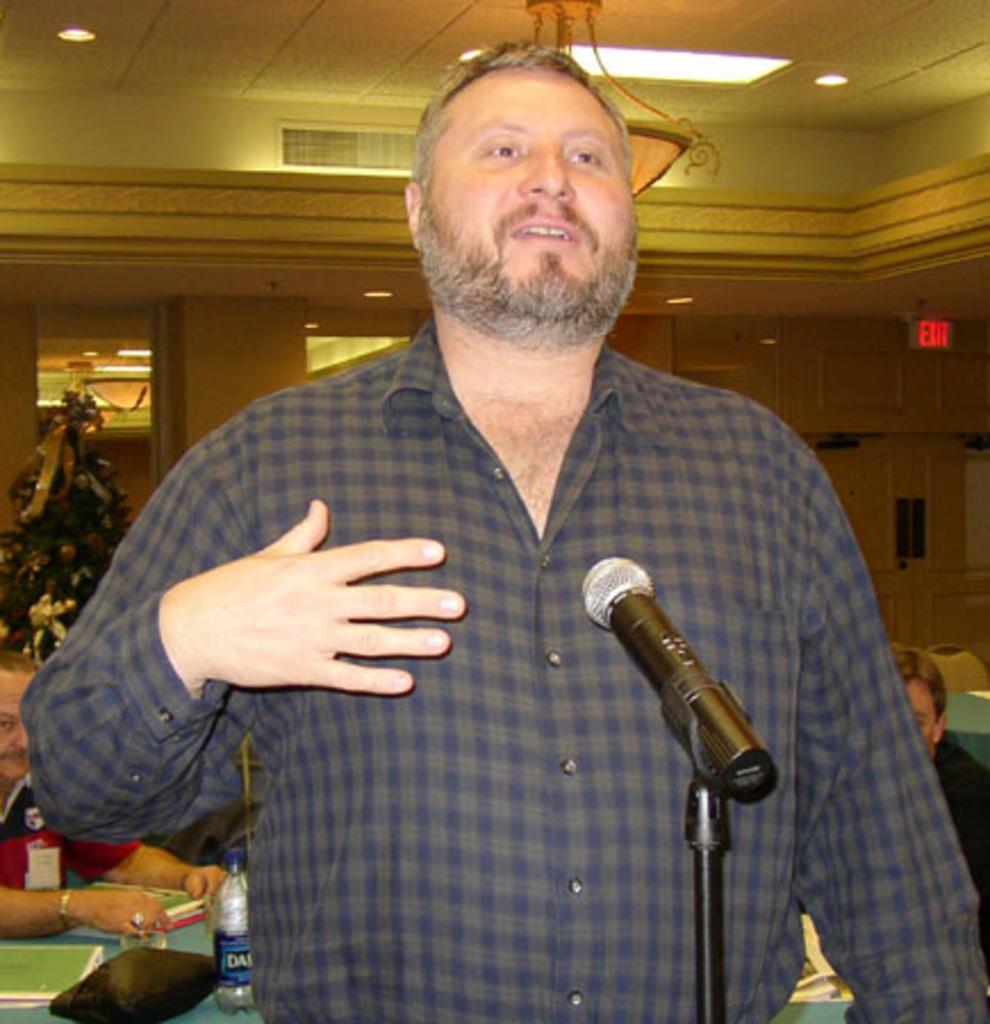In one or two sentences, can you explain what this image depicts? In this picture we can see man talking in front of mic and in background we can see Christmas tree, pillar, light, person sitting on chairs, bottle, books on table. 